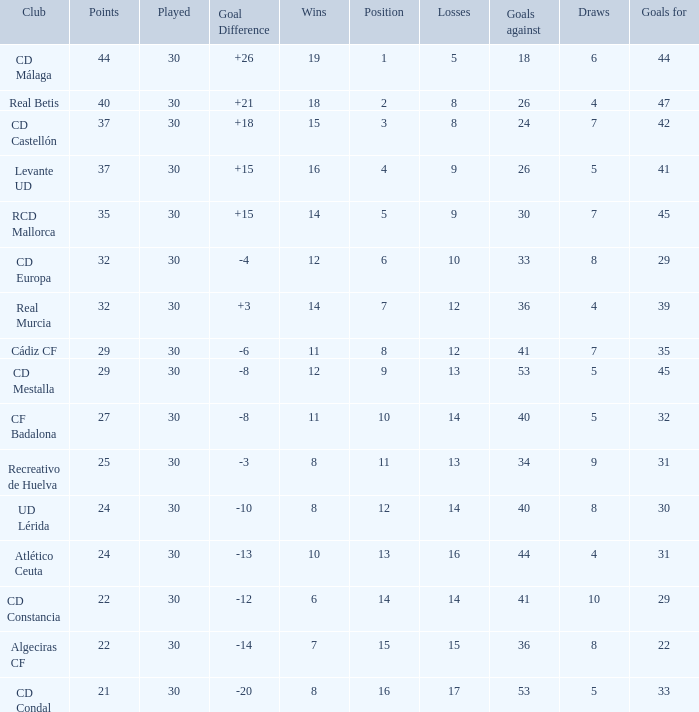What is the number of losses when the goal difference was -8, and position is smaller than 10? 1.0. 